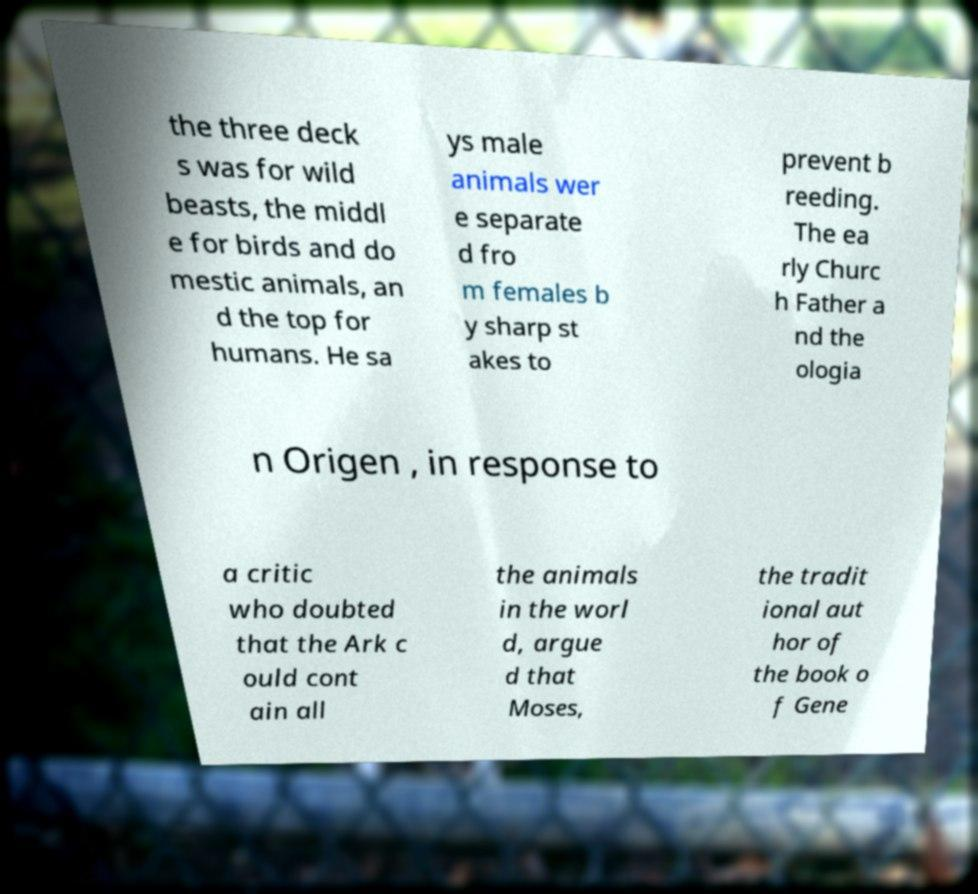Can you read and provide the text displayed in the image?This photo seems to have some interesting text. Can you extract and type it out for me? the three deck s was for wild beasts, the middl e for birds and do mestic animals, an d the top for humans. He sa ys male animals wer e separate d fro m females b y sharp st akes to prevent b reeding. The ea rly Churc h Father a nd the ologia n Origen , in response to a critic who doubted that the Ark c ould cont ain all the animals in the worl d, argue d that Moses, the tradit ional aut hor of the book o f Gene 